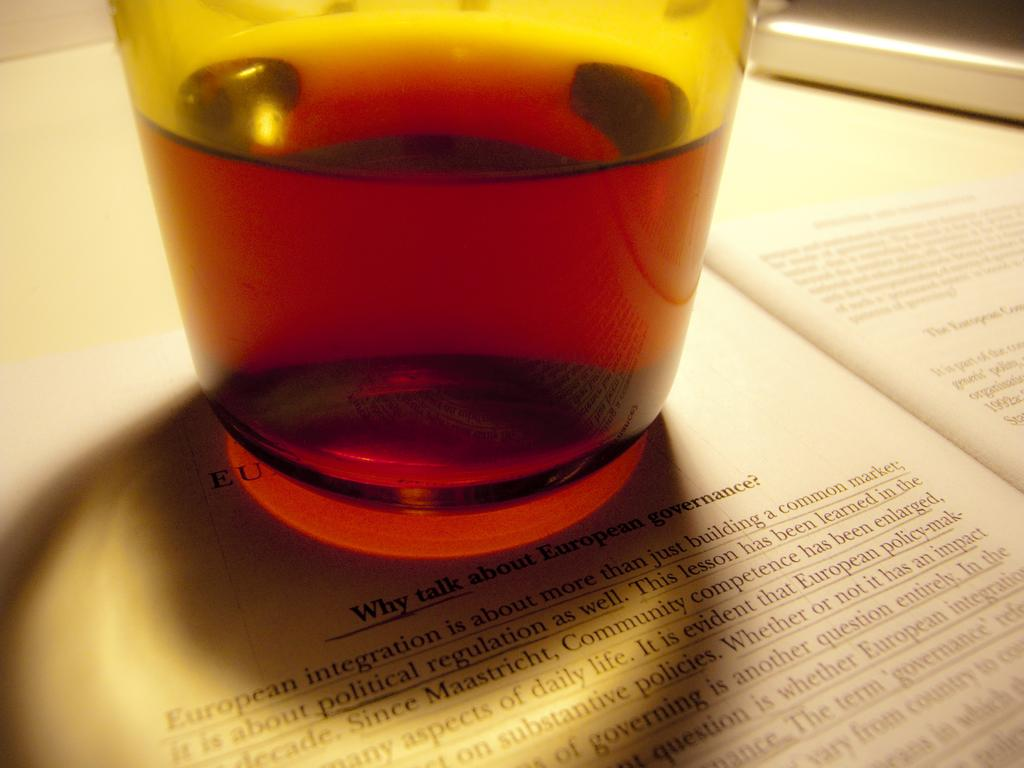<image>
Share a concise interpretation of the image provided. A drink sits on a book page over the header "why talk about European governance?" 